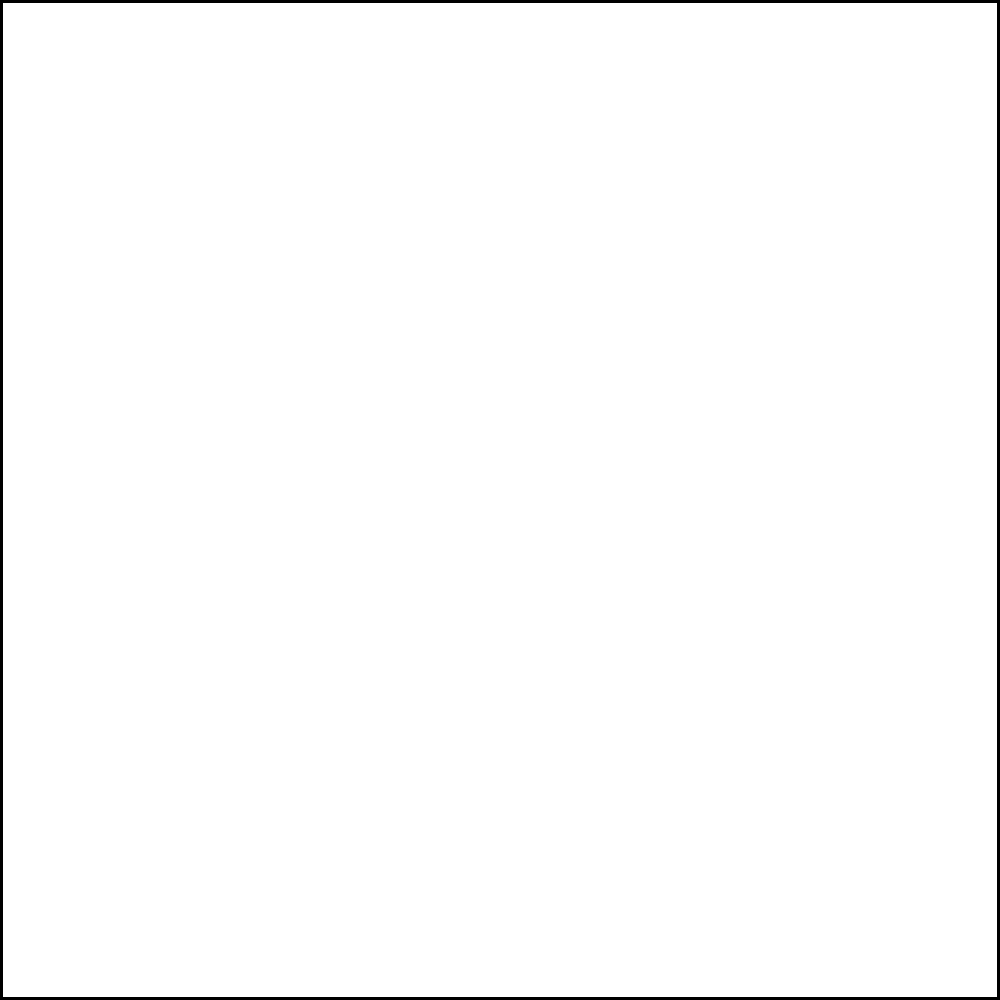In the diagram, square OABC is rotated 90° counterclockwise around point O. What are the coordinates of point A after the rotation? To solve this problem, let's follow these steps:

1) First, we need to understand what a 90° counterclockwise rotation does to a point:
   - It transforms (x, y) to (-y, x)

2) We can see that the original coordinates of point A are (2, 0)

3) Applying the rotation transformation:
   - x becomes -y: -0 = 0
   - y becomes x: 2

4) Therefore, after rotation, point A moves to (0, 2)

5) We can verify this visually:
   - A starts at (2, 0), which is on the positive x-axis
   - After a 90° counterclockwise rotation, it should end up on the positive y-axis
   - (0, 2) is indeed on the positive y-axis, 2 units up from the origin

This transformation effectively moves A to where C was originally, which makes sense for a 90° rotation of a square.
Answer: (0, 2) 